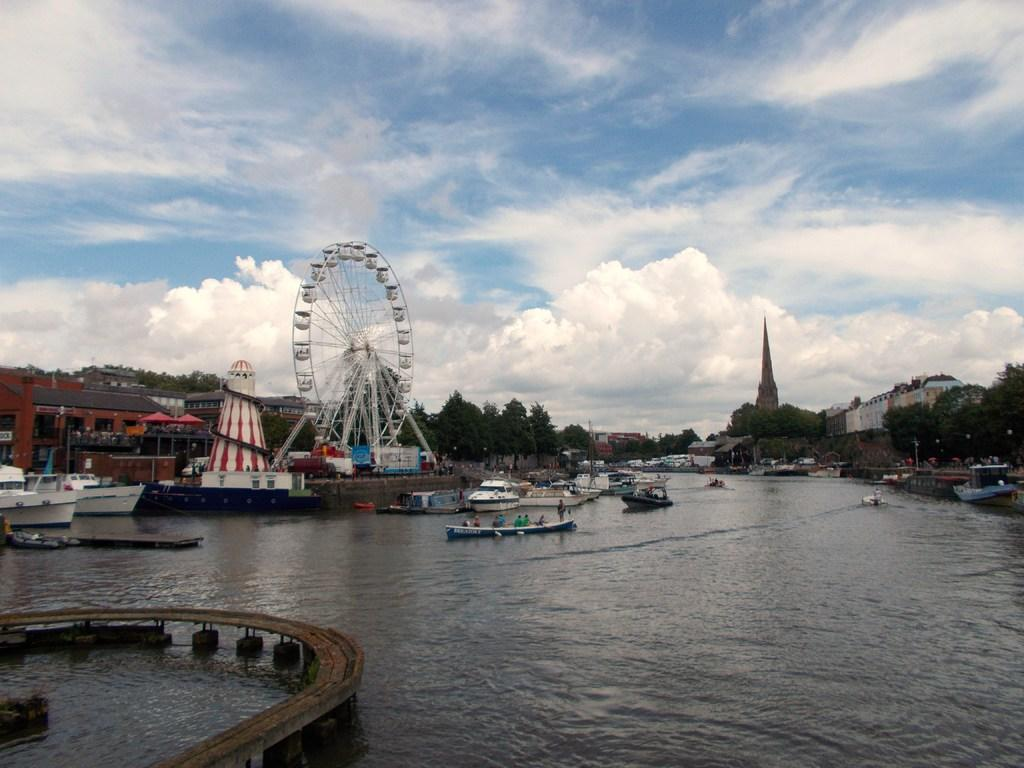What is the primary element in the image? There is water in the image. What can be seen floating on the water? There are boats in the water. What type of vegetation is visible in the image? There are trees visible in the image. What type of structures can be seen in the image? There are buildings in the image. What type of amusement ride is present in the image? There is a giant wheel in the image. What is visible in the background of the image? There are clouds and the sky visible in the background of the image. How many tin babies are sitting on the giant wheel in the image? There are no tin babies present in the image; the giant wheel is an amusement ride and does not have any babies on it. 